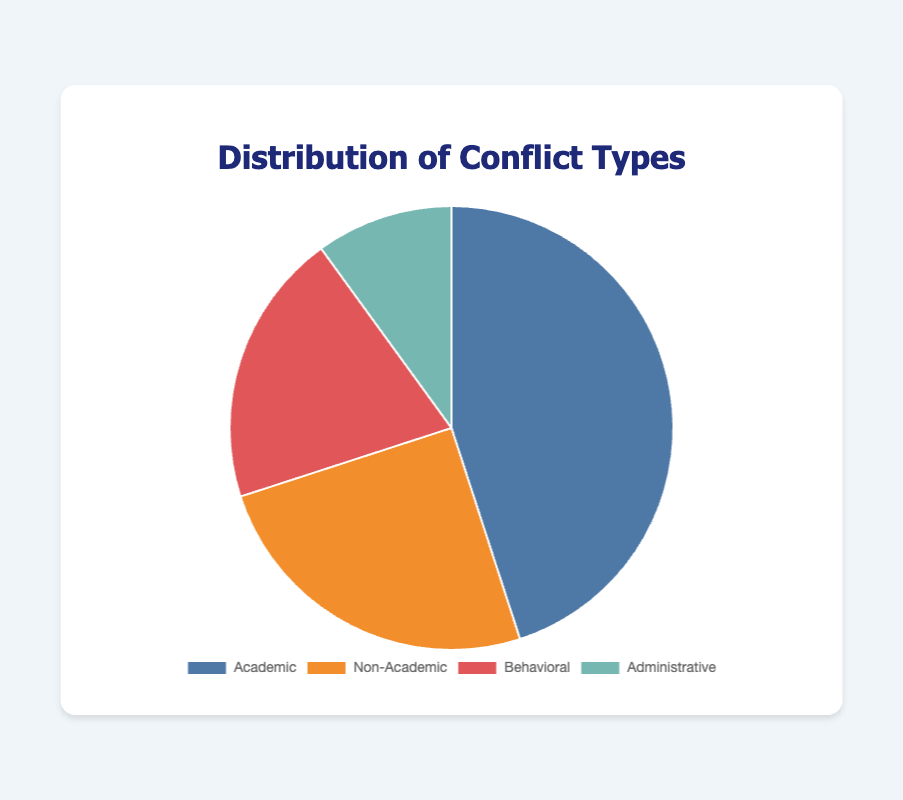what percentage of conflicts are academic? The pie chart shows that the academic conflicts account for 45% of the total conflicts.
Answer: 45% how many types of conflicts are shown in the pie chart? The chart has four slices representing different types of conflicts: Academic, Non-Academic, Behavioral, and Administrative.
Answer: 4 which type of conflict has the smallest proportion? Observing the pie chart, the Administrative slice is the smallest, indicating it has the smallest proportion at 10%.
Answer: Administrative what is the combined percentage of Non-Academic and Behavioral conflicts? The Non-Academic conflicts make up 25%, and the Behavioral conflicts make up 20%. Adding these percentages together gives 25% + 20% = 45%.
Answer: 45% how much larger is the proportion of Academic conflicts compared to Administrative conflicts? The Academic conflicts account for 45%, and the Administrative conflicts for 10%. The difference is 45% - 10% = 35%.
Answer: 35% which conflict types together make up half of the total conflicts? Combining the Non-Academic (25%) and Behavioral (20%) types gives us 25% + 20% = 45%. This is less than half. If we add Administrative (10%), the total is 25% + 20% + 10% = 55%, which is more than half. Hence, there isn't a combination of types that exactly make up 50%, but the closest would be Academic alone at 45%.
Answer: None exactly; closest is Academic at 45% what is the ratio of Academic conflicts to Non-Academic conflicts? Academic conflicts are 45%, while Non-Academic conflicts are 25%. The ratio is 45:25, which simplifies to 9:5.
Answer: 9:5 if you were to combine Non-Academic and Administrative conflicts, would they be more than Academic conflicts? Non-Academic conflicts are 25% and Administrative conflicts are 10%. Combined, they are 25% + 10% = 35%, which is less than the 45% of Academic conflicts.
Answer: No what average percentage of conflicts do Behavioral and Administrative types represent individually? Behavioral conflicts are 20% and Administrative conflicts are 10%. The average of these two percentages is (20% + 10%) / 2 = 15%.
Answer: 15% which slice is represented by the color blue in the pie chart? Looking at the pie chart colors, Academic conflicts are represented by the color blue.
Answer: Academic 